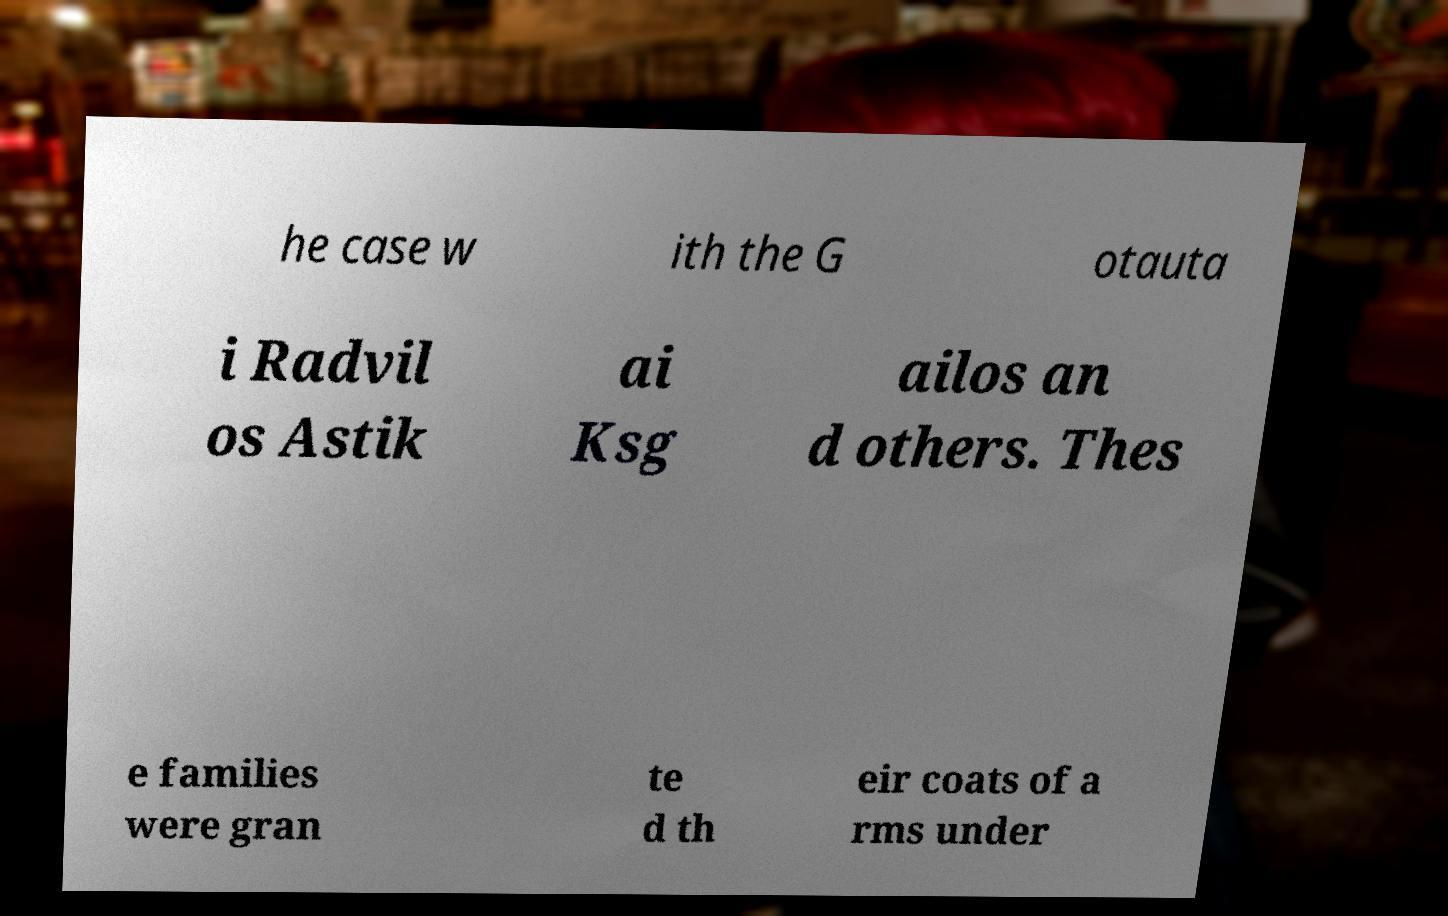What messages or text are displayed in this image? I need them in a readable, typed format. he case w ith the G otauta i Radvil os Astik ai Ksg ailos an d others. Thes e families were gran te d th eir coats of a rms under 